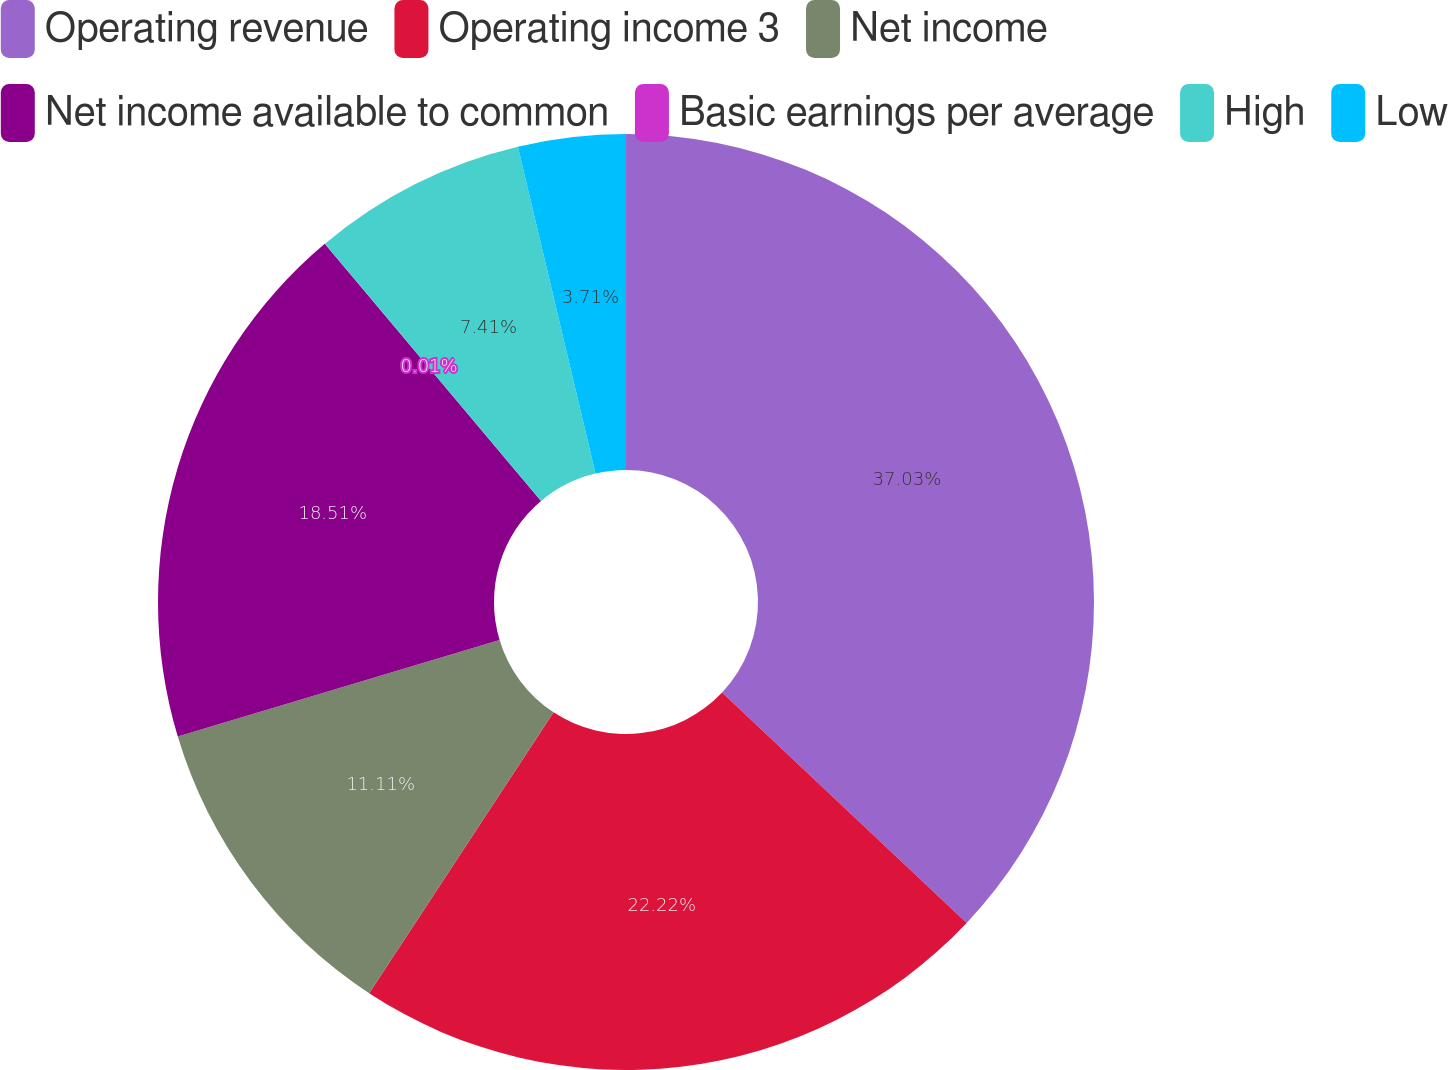Convert chart to OTSL. <chart><loc_0><loc_0><loc_500><loc_500><pie_chart><fcel>Operating revenue<fcel>Operating income 3<fcel>Net income<fcel>Net income available to common<fcel>Basic earnings per average<fcel>High<fcel>Low<nl><fcel>37.02%<fcel>22.22%<fcel>11.11%<fcel>18.51%<fcel>0.01%<fcel>7.41%<fcel>3.71%<nl></chart> 